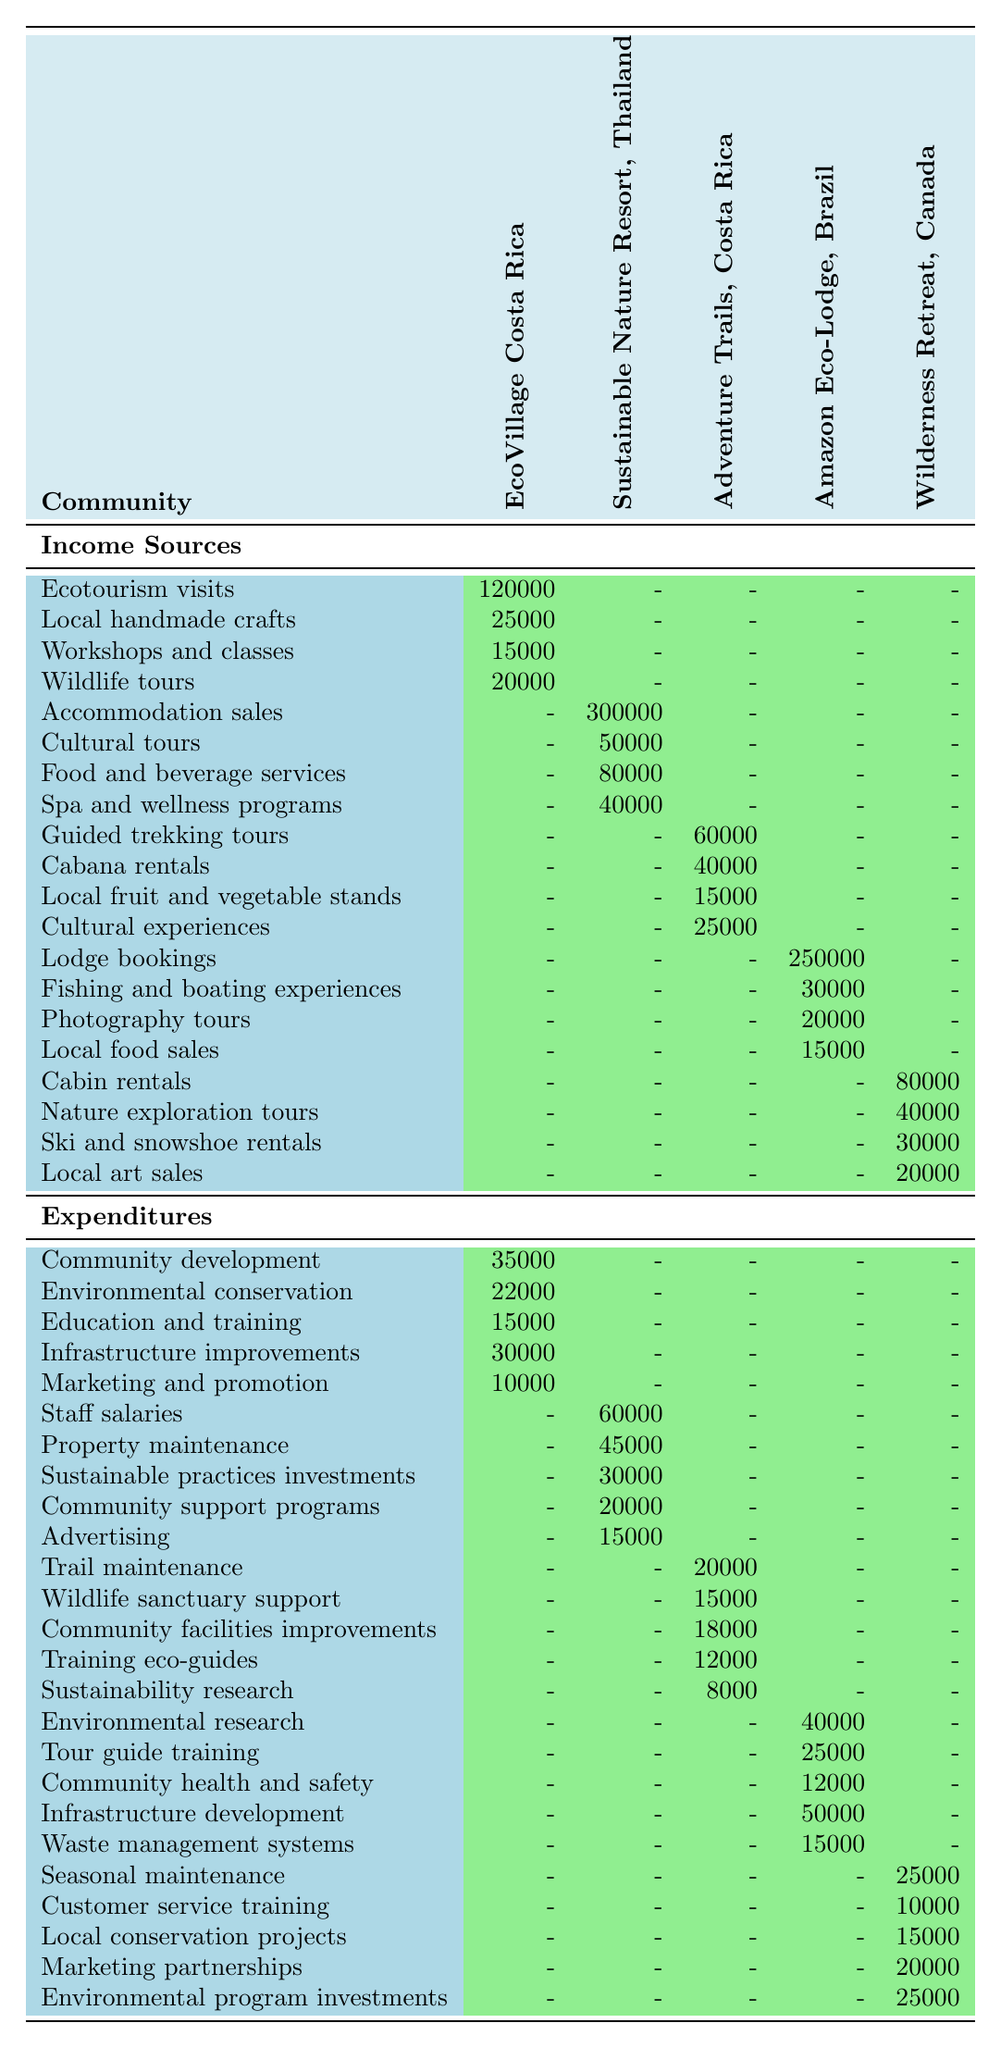What is the income from ecotourism visits in EcoVillage Costa Rica? The table lists the income from ecotourism visits specifically for EcoVillage Costa Rica, which is stated as 120,000.
Answer: 120000 What is the total income for Sustainable Nature Resort, Thailand? We add all the income sources: accommodation sales (300,000), cultural tours (50,000), food and beverage services (80,000), and spa and wellness programs (40,000). This totals to 300,000 + 50,000 + 80,000 + 40,000 = 470,000.
Answer: 470000 Does Adventure Trails, Costa Rica have any income from local handmade crafts? The table does not list any income from local handmade crafts for Adventure Trails, Costa Rica, only from guided trekking tours, cabana rentals, local fruit stands, and cultural experiences.
Answer: No What is the average amount spent on community development across all communities? The expenditures on community development in the table are: EcoVillage Costa Rica (35,000), and no entries for the others. We total these and divide by the number of communities (1 with data), yielding 35,000/1 = 35,000.
Answer: 35000 Which community has the highest income from lodge bookings? The Amazon Eco-Lodge, Brazil shows lodge bookings as 250,000, while other communities do not have any lodge booking income listed, making it the highest.
Answer: Amazon Eco-Lodge, Brazil What is the total expenditure for Wilderness Retreat, Canada? We sum the expenditures: seasonal maintenance (25,000), customer service training (10,000), local conservation projects (15,000), marketing partnerships (20,000), and environmental program investments (25,000). This results in 25,000 + 10,000 + 15,000 + 20,000 + 25,000 = 105,000.
Answer: 105000 Is the income from cultural experiences higher than the income from fishing and boating experiences? From the table, the income from cultural experiences in Adventure Trails, Costa Rica is 25,000, while the income from fishing and boating experiences in Amazon Eco-Lodge, Brazil is 30,000. Since 25,000 is less than 30,000, the statement is false.
Answer: No What expenditure type is shared by multiple communities involving training? The expenditure types for training that appear in the table are Education and training (EcoVillage Costa Rica) and Training eco-guides (Adventure Trails, Costa Rica) and Tour guide training (Amazon Eco-Lodge, Brazil). These types suggest various training expenditures shared among selected communities.
Answer: Yes 